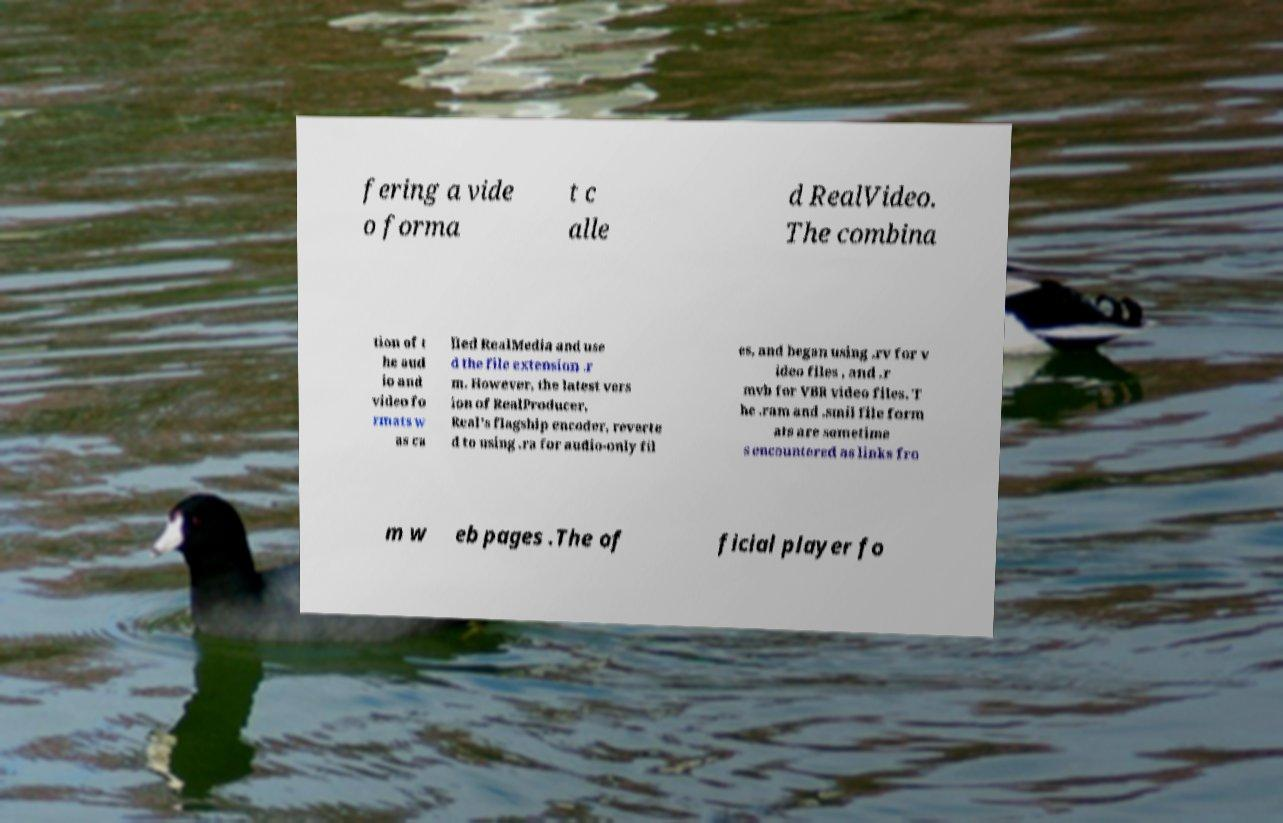For documentation purposes, I need the text within this image transcribed. Could you provide that? fering a vide o forma t c alle d RealVideo. The combina tion of t he aud io and video fo rmats w as ca lled RealMedia and use d the file extension .r m. However, the latest vers ion of RealProducer, Real's flagship encoder, reverte d to using .ra for audio-only fil es, and began using .rv for v ideo files , and .r mvb for VBR video files. T he .ram and .smil file form ats are sometime s encountered as links fro m w eb pages .The of ficial player fo 